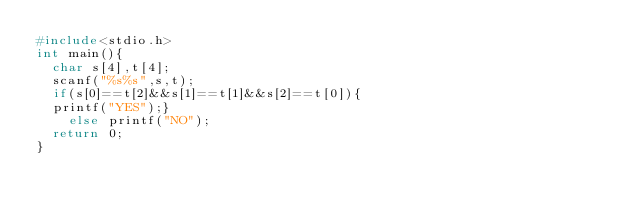Convert code to text. <code><loc_0><loc_0><loc_500><loc_500><_C_>#include<stdio.h>
int main(){
  char s[4],t[4];
  scanf("%s%s",s,t);
  if(s[0]==t[2]&&s[1]==t[1]&&s[2]==t[0]){
	printf("YES");}
    else printf("NO");
  return 0;
}
</code> 